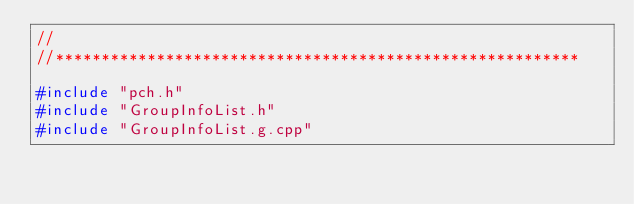Convert code to text. <code><loc_0><loc_0><loc_500><loc_500><_C++_>//
//*********************************************************

#include "pch.h"
#include "GroupInfoList.h"
#include "GroupInfoList.g.cpp"
</code> 